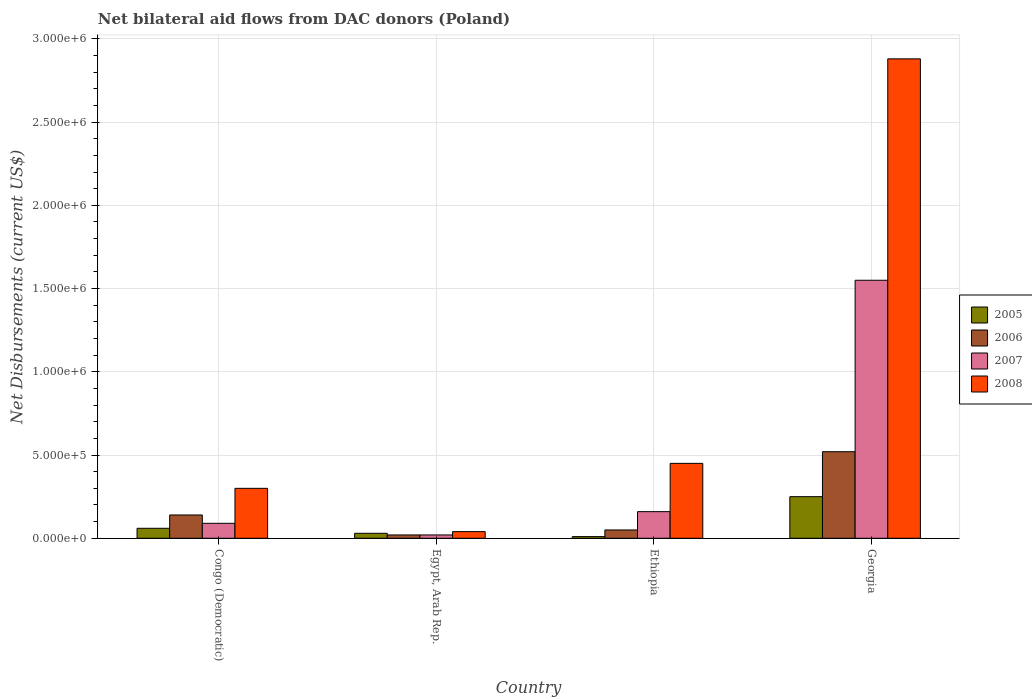How many bars are there on the 2nd tick from the right?
Offer a terse response. 4. What is the label of the 3rd group of bars from the left?
Your answer should be compact. Ethiopia. In how many cases, is the number of bars for a given country not equal to the number of legend labels?
Your answer should be very brief. 0. What is the net bilateral aid flows in 2008 in Egypt, Arab Rep.?
Keep it short and to the point. 4.00e+04. Across all countries, what is the maximum net bilateral aid flows in 2005?
Your answer should be compact. 2.50e+05. Across all countries, what is the minimum net bilateral aid flows in 2007?
Give a very brief answer. 2.00e+04. In which country was the net bilateral aid flows in 2008 maximum?
Your answer should be very brief. Georgia. In which country was the net bilateral aid flows in 2007 minimum?
Your response must be concise. Egypt, Arab Rep. What is the total net bilateral aid flows in 2005 in the graph?
Offer a very short reply. 3.50e+05. What is the difference between the net bilateral aid flows in 2008 in Congo (Democratic) and that in Georgia?
Provide a succinct answer. -2.58e+06. What is the difference between the net bilateral aid flows in 2007 in Egypt, Arab Rep. and the net bilateral aid flows in 2006 in Congo (Democratic)?
Make the answer very short. -1.20e+05. What is the average net bilateral aid flows in 2008 per country?
Provide a short and direct response. 9.18e+05. What is the difference between the net bilateral aid flows of/in 2007 and net bilateral aid flows of/in 2005 in Georgia?
Your answer should be compact. 1.30e+06. In how many countries, is the net bilateral aid flows in 2007 greater than 2300000 US$?
Ensure brevity in your answer.  0. What is the ratio of the net bilateral aid flows in 2006 in Congo (Democratic) to that in Ethiopia?
Keep it short and to the point. 2.8. What is the difference between the highest and the second highest net bilateral aid flows in 2006?
Provide a succinct answer. 3.80e+05. In how many countries, is the net bilateral aid flows in 2008 greater than the average net bilateral aid flows in 2008 taken over all countries?
Give a very brief answer. 1. Is it the case that in every country, the sum of the net bilateral aid flows in 2007 and net bilateral aid flows in 2008 is greater than the sum of net bilateral aid flows in 2006 and net bilateral aid flows in 2005?
Your answer should be compact. Yes. How many bars are there?
Give a very brief answer. 16. Are all the bars in the graph horizontal?
Ensure brevity in your answer.  No. How many countries are there in the graph?
Make the answer very short. 4. What is the difference between two consecutive major ticks on the Y-axis?
Offer a very short reply. 5.00e+05. Are the values on the major ticks of Y-axis written in scientific E-notation?
Provide a short and direct response. Yes. Does the graph contain any zero values?
Provide a short and direct response. No. Does the graph contain grids?
Your answer should be compact. Yes. Where does the legend appear in the graph?
Keep it short and to the point. Center right. How many legend labels are there?
Offer a very short reply. 4. What is the title of the graph?
Your answer should be compact. Net bilateral aid flows from DAC donors (Poland). What is the label or title of the Y-axis?
Your response must be concise. Net Disbursements (current US$). What is the Net Disbursements (current US$) in 2006 in Congo (Democratic)?
Make the answer very short. 1.40e+05. What is the Net Disbursements (current US$) in 2008 in Congo (Democratic)?
Your answer should be very brief. 3.00e+05. What is the Net Disbursements (current US$) of 2007 in Egypt, Arab Rep.?
Ensure brevity in your answer.  2.00e+04. What is the Net Disbursements (current US$) in 2006 in Ethiopia?
Give a very brief answer. 5.00e+04. What is the Net Disbursements (current US$) of 2005 in Georgia?
Offer a very short reply. 2.50e+05. What is the Net Disbursements (current US$) of 2006 in Georgia?
Provide a succinct answer. 5.20e+05. What is the Net Disbursements (current US$) in 2007 in Georgia?
Make the answer very short. 1.55e+06. What is the Net Disbursements (current US$) of 2008 in Georgia?
Offer a very short reply. 2.88e+06. Across all countries, what is the maximum Net Disbursements (current US$) of 2005?
Ensure brevity in your answer.  2.50e+05. Across all countries, what is the maximum Net Disbursements (current US$) of 2006?
Offer a terse response. 5.20e+05. Across all countries, what is the maximum Net Disbursements (current US$) of 2007?
Provide a succinct answer. 1.55e+06. Across all countries, what is the maximum Net Disbursements (current US$) of 2008?
Make the answer very short. 2.88e+06. Across all countries, what is the minimum Net Disbursements (current US$) in 2005?
Provide a short and direct response. 10000. What is the total Net Disbursements (current US$) of 2006 in the graph?
Provide a succinct answer. 7.30e+05. What is the total Net Disbursements (current US$) in 2007 in the graph?
Your answer should be compact. 1.82e+06. What is the total Net Disbursements (current US$) in 2008 in the graph?
Make the answer very short. 3.67e+06. What is the difference between the Net Disbursements (current US$) of 2005 in Congo (Democratic) and that in Egypt, Arab Rep.?
Provide a succinct answer. 3.00e+04. What is the difference between the Net Disbursements (current US$) in 2007 in Congo (Democratic) and that in Egypt, Arab Rep.?
Make the answer very short. 7.00e+04. What is the difference between the Net Disbursements (current US$) in 2005 in Congo (Democratic) and that in Ethiopia?
Ensure brevity in your answer.  5.00e+04. What is the difference between the Net Disbursements (current US$) of 2006 in Congo (Democratic) and that in Ethiopia?
Provide a short and direct response. 9.00e+04. What is the difference between the Net Disbursements (current US$) in 2008 in Congo (Democratic) and that in Ethiopia?
Keep it short and to the point. -1.50e+05. What is the difference between the Net Disbursements (current US$) of 2005 in Congo (Democratic) and that in Georgia?
Give a very brief answer. -1.90e+05. What is the difference between the Net Disbursements (current US$) of 2006 in Congo (Democratic) and that in Georgia?
Ensure brevity in your answer.  -3.80e+05. What is the difference between the Net Disbursements (current US$) of 2007 in Congo (Democratic) and that in Georgia?
Provide a short and direct response. -1.46e+06. What is the difference between the Net Disbursements (current US$) of 2008 in Congo (Democratic) and that in Georgia?
Your answer should be very brief. -2.58e+06. What is the difference between the Net Disbursements (current US$) in 2006 in Egypt, Arab Rep. and that in Ethiopia?
Ensure brevity in your answer.  -3.00e+04. What is the difference between the Net Disbursements (current US$) in 2008 in Egypt, Arab Rep. and that in Ethiopia?
Give a very brief answer. -4.10e+05. What is the difference between the Net Disbursements (current US$) in 2005 in Egypt, Arab Rep. and that in Georgia?
Your answer should be very brief. -2.20e+05. What is the difference between the Net Disbursements (current US$) of 2006 in Egypt, Arab Rep. and that in Georgia?
Provide a succinct answer. -5.00e+05. What is the difference between the Net Disbursements (current US$) in 2007 in Egypt, Arab Rep. and that in Georgia?
Provide a short and direct response. -1.53e+06. What is the difference between the Net Disbursements (current US$) of 2008 in Egypt, Arab Rep. and that in Georgia?
Provide a succinct answer. -2.84e+06. What is the difference between the Net Disbursements (current US$) of 2006 in Ethiopia and that in Georgia?
Offer a terse response. -4.70e+05. What is the difference between the Net Disbursements (current US$) in 2007 in Ethiopia and that in Georgia?
Your response must be concise. -1.39e+06. What is the difference between the Net Disbursements (current US$) of 2008 in Ethiopia and that in Georgia?
Provide a short and direct response. -2.43e+06. What is the difference between the Net Disbursements (current US$) in 2005 in Congo (Democratic) and the Net Disbursements (current US$) in 2006 in Egypt, Arab Rep.?
Offer a very short reply. 4.00e+04. What is the difference between the Net Disbursements (current US$) of 2005 in Congo (Democratic) and the Net Disbursements (current US$) of 2008 in Egypt, Arab Rep.?
Offer a terse response. 2.00e+04. What is the difference between the Net Disbursements (current US$) in 2006 in Congo (Democratic) and the Net Disbursements (current US$) in 2007 in Egypt, Arab Rep.?
Provide a succinct answer. 1.20e+05. What is the difference between the Net Disbursements (current US$) in 2006 in Congo (Democratic) and the Net Disbursements (current US$) in 2008 in Egypt, Arab Rep.?
Your answer should be compact. 1.00e+05. What is the difference between the Net Disbursements (current US$) of 2007 in Congo (Democratic) and the Net Disbursements (current US$) of 2008 in Egypt, Arab Rep.?
Your answer should be compact. 5.00e+04. What is the difference between the Net Disbursements (current US$) of 2005 in Congo (Democratic) and the Net Disbursements (current US$) of 2008 in Ethiopia?
Provide a succinct answer. -3.90e+05. What is the difference between the Net Disbursements (current US$) of 2006 in Congo (Democratic) and the Net Disbursements (current US$) of 2008 in Ethiopia?
Provide a succinct answer. -3.10e+05. What is the difference between the Net Disbursements (current US$) in 2007 in Congo (Democratic) and the Net Disbursements (current US$) in 2008 in Ethiopia?
Ensure brevity in your answer.  -3.60e+05. What is the difference between the Net Disbursements (current US$) in 2005 in Congo (Democratic) and the Net Disbursements (current US$) in 2006 in Georgia?
Ensure brevity in your answer.  -4.60e+05. What is the difference between the Net Disbursements (current US$) in 2005 in Congo (Democratic) and the Net Disbursements (current US$) in 2007 in Georgia?
Your response must be concise. -1.49e+06. What is the difference between the Net Disbursements (current US$) of 2005 in Congo (Democratic) and the Net Disbursements (current US$) of 2008 in Georgia?
Offer a terse response. -2.82e+06. What is the difference between the Net Disbursements (current US$) of 2006 in Congo (Democratic) and the Net Disbursements (current US$) of 2007 in Georgia?
Provide a short and direct response. -1.41e+06. What is the difference between the Net Disbursements (current US$) in 2006 in Congo (Democratic) and the Net Disbursements (current US$) in 2008 in Georgia?
Make the answer very short. -2.74e+06. What is the difference between the Net Disbursements (current US$) in 2007 in Congo (Democratic) and the Net Disbursements (current US$) in 2008 in Georgia?
Offer a very short reply. -2.79e+06. What is the difference between the Net Disbursements (current US$) in 2005 in Egypt, Arab Rep. and the Net Disbursements (current US$) in 2006 in Ethiopia?
Provide a succinct answer. -2.00e+04. What is the difference between the Net Disbursements (current US$) of 2005 in Egypt, Arab Rep. and the Net Disbursements (current US$) of 2007 in Ethiopia?
Provide a short and direct response. -1.30e+05. What is the difference between the Net Disbursements (current US$) in 2005 in Egypt, Arab Rep. and the Net Disbursements (current US$) in 2008 in Ethiopia?
Offer a terse response. -4.20e+05. What is the difference between the Net Disbursements (current US$) of 2006 in Egypt, Arab Rep. and the Net Disbursements (current US$) of 2007 in Ethiopia?
Your answer should be very brief. -1.40e+05. What is the difference between the Net Disbursements (current US$) in 2006 in Egypt, Arab Rep. and the Net Disbursements (current US$) in 2008 in Ethiopia?
Make the answer very short. -4.30e+05. What is the difference between the Net Disbursements (current US$) in 2007 in Egypt, Arab Rep. and the Net Disbursements (current US$) in 2008 in Ethiopia?
Offer a terse response. -4.30e+05. What is the difference between the Net Disbursements (current US$) of 2005 in Egypt, Arab Rep. and the Net Disbursements (current US$) of 2006 in Georgia?
Your answer should be compact. -4.90e+05. What is the difference between the Net Disbursements (current US$) of 2005 in Egypt, Arab Rep. and the Net Disbursements (current US$) of 2007 in Georgia?
Provide a short and direct response. -1.52e+06. What is the difference between the Net Disbursements (current US$) of 2005 in Egypt, Arab Rep. and the Net Disbursements (current US$) of 2008 in Georgia?
Provide a short and direct response. -2.85e+06. What is the difference between the Net Disbursements (current US$) in 2006 in Egypt, Arab Rep. and the Net Disbursements (current US$) in 2007 in Georgia?
Make the answer very short. -1.53e+06. What is the difference between the Net Disbursements (current US$) of 2006 in Egypt, Arab Rep. and the Net Disbursements (current US$) of 2008 in Georgia?
Give a very brief answer. -2.86e+06. What is the difference between the Net Disbursements (current US$) in 2007 in Egypt, Arab Rep. and the Net Disbursements (current US$) in 2008 in Georgia?
Provide a succinct answer. -2.86e+06. What is the difference between the Net Disbursements (current US$) in 2005 in Ethiopia and the Net Disbursements (current US$) in 2006 in Georgia?
Offer a very short reply. -5.10e+05. What is the difference between the Net Disbursements (current US$) of 2005 in Ethiopia and the Net Disbursements (current US$) of 2007 in Georgia?
Your answer should be compact. -1.54e+06. What is the difference between the Net Disbursements (current US$) in 2005 in Ethiopia and the Net Disbursements (current US$) in 2008 in Georgia?
Offer a very short reply. -2.87e+06. What is the difference between the Net Disbursements (current US$) in 2006 in Ethiopia and the Net Disbursements (current US$) in 2007 in Georgia?
Offer a very short reply. -1.50e+06. What is the difference between the Net Disbursements (current US$) of 2006 in Ethiopia and the Net Disbursements (current US$) of 2008 in Georgia?
Offer a terse response. -2.83e+06. What is the difference between the Net Disbursements (current US$) of 2007 in Ethiopia and the Net Disbursements (current US$) of 2008 in Georgia?
Your response must be concise. -2.72e+06. What is the average Net Disbursements (current US$) in 2005 per country?
Give a very brief answer. 8.75e+04. What is the average Net Disbursements (current US$) of 2006 per country?
Provide a short and direct response. 1.82e+05. What is the average Net Disbursements (current US$) in 2007 per country?
Keep it short and to the point. 4.55e+05. What is the average Net Disbursements (current US$) of 2008 per country?
Keep it short and to the point. 9.18e+05. What is the difference between the Net Disbursements (current US$) of 2005 and Net Disbursements (current US$) of 2007 in Congo (Democratic)?
Give a very brief answer. -3.00e+04. What is the difference between the Net Disbursements (current US$) in 2005 and Net Disbursements (current US$) in 2008 in Congo (Democratic)?
Offer a very short reply. -2.40e+05. What is the difference between the Net Disbursements (current US$) of 2006 and Net Disbursements (current US$) of 2008 in Congo (Democratic)?
Give a very brief answer. -1.60e+05. What is the difference between the Net Disbursements (current US$) of 2007 and Net Disbursements (current US$) of 2008 in Congo (Democratic)?
Make the answer very short. -2.10e+05. What is the difference between the Net Disbursements (current US$) of 2005 and Net Disbursements (current US$) of 2006 in Egypt, Arab Rep.?
Provide a short and direct response. 10000. What is the difference between the Net Disbursements (current US$) of 2005 and Net Disbursements (current US$) of 2008 in Egypt, Arab Rep.?
Your answer should be very brief. -10000. What is the difference between the Net Disbursements (current US$) in 2006 and Net Disbursements (current US$) in 2007 in Egypt, Arab Rep.?
Provide a short and direct response. 0. What is the difference between the Net Disbursements (current US$) of 2007 and Net Disbursements (current US$) of 2008 in Egypt, Arab Rep.?
Give a very brief answer. -2.00e+04. What is the difference between the Net Disbursements (current US$) in 2005 and Net Disbursements (current US$) in 2006 in Ethiopia?
Give a very brief answer. -4.00e+04. What is the difference between the Net Disbursements (current US$) in 2005 and Net Disbursements (current US$) in 2008 in Ethiopia?
Give a very brief answer. -4.40e+05. What is the difference between the Net Disbursements (current US$) in 2006 and Net Disbursements (current US$) in 2008 in Ethiopia?
Your answer should be compact. -4.00e+05. What is the difference between the Net Disbursements (current US$) of 2005 and Net Disbursements (current US$) of 2007 in Georgia?
Give a very brief answer. -1.30e+06. What is the difference between the Net Disbursements (current US$) of 2005 and Net Disbursements (current US$) of 2008 in Georgia?
Ensure brevity in your answer.  -2.63e+06. What is the difference between the Net Disbursements (current US$) of 2006 and Net Disbursements (current US$) of 2007 in Georgia?
Give a very brief answer. -1.03e+06. What is the difference between the Net Disbursements (current US$) in 2006 and Net Disbursements (current US$) in 2008 in Georgia?
Provide a short and direct response. -2.36e+06. What is the difference between the Net Disbursements (current US$) of 2007 and Net Disbursements (current US$) of 2008 in Georgia?
Your response must be concise. -1.33e+06. What is the ratio of the Net Disbursements (current US$) of 2008 in Congo (Democratic) to that in Egypt, Arab Rep.?
Provide a short and direct response. 7.5. What is the ratio of the Net Disbursements (current US$) in 2005 in Congo (Democratic) to that in Ethiopia?
Offer a very short reply. 6. What is the ratio of the Net Disbursements (current US$) of 2007 in Congo (Democratic) to that in Ethiopia?
Your answer should be very brief. 0.56. What is the ratio of the Net Disbursements (current US$) in 2008 in Congo (Democratic) to that in Ethiopia?
Ensure brevity in your answer.  0.67. What is the ratio of the Net Disbursements (current US$) of 2005 in Congo (Democratic) to that in Georgia?
Keep it short and to the point. 0.24. What is the ratio of the Net Disbursements (current US$) in 2006 in Congo (Democratic) to that in Georgia?
Keep it short and to the point. 0.27. What is the ratio of the Net Disbursements (current US$) in 2007 in Congo (Democratic) to that in Georgia?
Make the answer very short. 0.06. What is the ratio of the Net Disbursements (current US$) in 2008 in Congo (Democratic) to that in Georgia?
Provide a succinct answer. 0.1. What is the ratio of the Net Disbursements (current US$) of 2006 in Egypt, Arab Rep. to that in Ethiopia?
Keep it short and to the point. 0.4. What is the ratio of the Net Disbursements (current US$) in 2007 in Egypt, Arab Rep. to that in Ethiopia?
Your answer should be compact. 0.12. What is the ratio of the Net Disbursements (current US$) in 2008 in Egypt, Arab Rep. to that in Ethiopia?
Provide a succinct answer. 0.09. What is the ratio of the Net Disbursements (current US$) in 2005 in Egypt, Arab Rep. to that in Georgia?
Give a very brief answer. 0.12. What is the ratio of the Net Disbursements (current US$) of 2006 in Egypt, Arab Rep. to that in Georgia?
Provide a succinct answer. 0.04. What is the ratio of the Net Disbursements (current US$) in 2007 in Egypt, Arab Rep. to that in Georgia?
Provide a succinct answer. 0.01. What is the ratio of the Net Disbursements (current US$) in 2008 in Egypt, Arab Rep. to that in Georgia?
Offer a terse response. 0.01. What is the ratio of the Net Disbursements (current US$) in 2005 in Ethiopia to that in Georgia?
Give a very brief answer. 0.04. What is the ratio of the Net Disbursements (current US$) of 2006 in Ethiopia to that in Georgia?
Provide a succinct answer. 0.1. What is the ratio of the Net Disbursements (current US$) in 2007 in Ethiopia to that in Georgia?
Ensure brevity in your answer.  0.1. What is the ratio of the Net Disbursements (current US$) of 2008 in Ethiopia to that in Georgia?
Provide a succinct answer. 0.16. What is the difference between the highest and the second highest Net Disbursements (current US$) of 2007?
Give a very brief answer. 1.39e+06. What is the difference between the highest and the second highest Net Disbursements (current US$) in 2008?
Offer a very short reply. 2.43e+06. What is the difference between the highest and the lowest Net Disbursements (current US$) in 2006?
Provide a succinct answer. 5.00e+05. What is the difference between the highest and the lowest Net Disbursements (current US$) of 2007?
Offer a very short reply. 1.53e+06. What is the difference between the highest and the lowest Net Disbursements (current US$) in 2008?
Provide a succinct answer. 2.84e+06. 